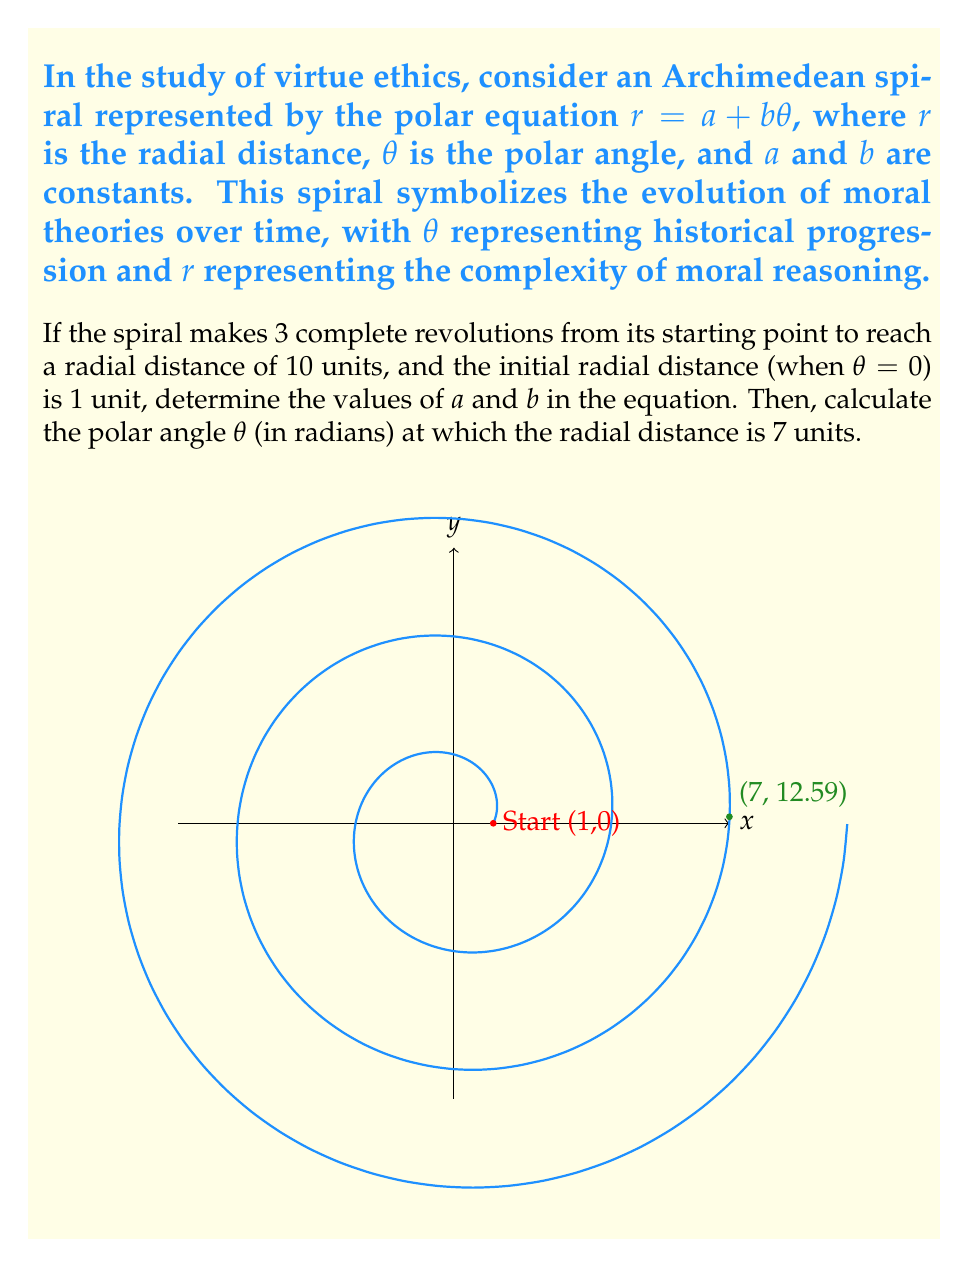Give your solution to this math problem. Let's approach this step-by-step:

1) We know that $r = a + b\theta$ is the equation of the Archimedean spiral.

2) Given information:
   - Initial radial distance (when $\theta = 0$) is 1 unit, so $a = 1$
   - After 3 complete revolutions, $r = 10$ units
   - 3 complete revolutions means $\theta = 6\pi$ radians

3) Let's find $b$ using the information from step 2:
   $10 = 1 + b(6\pi)$
   $9 = 6\pi b$
   $b = \frac{9}{6\pi} = \frac{3}{2\pi} \approx 0.477$

4) Now we have the complete equation: $r = 1 + \frac{3}{2\pi}\theta$

5) To find $\theta$ when $r = 7$, we substitute these values into our equation:
   $7 = 1 + \frac{3}{2\pi}\theta$
   $6 = \frac{3}{2\pi}\theta$
   $\theta = 6 \cdot \frac{2\pi}{3} = 4\pi \approx 12.57$ radians

Therefore, the radial distance is 7 units when $\theta \approx 12.57$ radians.
Answer: $a = 1$, $b = \frac{3}{2\pi}$, $\theta \approx 12.57$ radians 